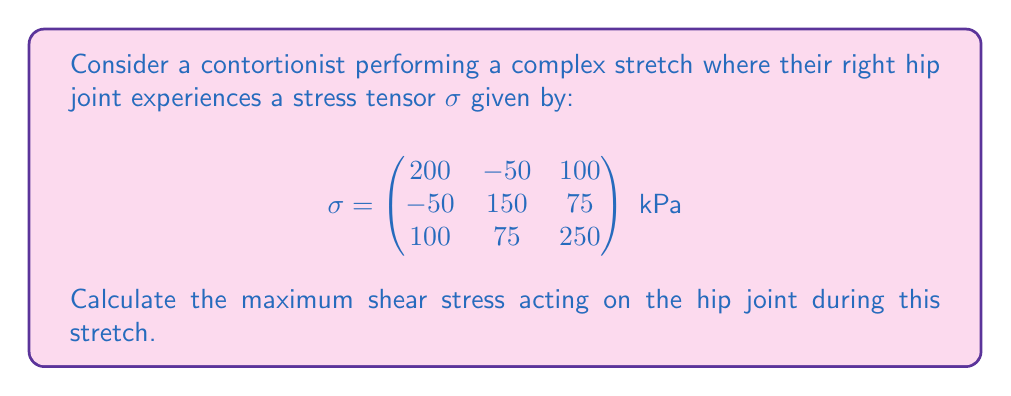Solve this math problem. To find the maximum shear stress, we need to follow these steps:

1) First, we need to calculate the principal stresses. These are the eigenvalues of the stress tensor.

2) The characteristic equation for the eigenvalues λ is:
   $$\det(\sigma - \lambda I) = 0$$

3) Expanding this determinant:
   $$(200-\lambda)(150-\lambda)(250-\lambda) - (-50)^2(250-\lambda) - 100^2(150-\lambda) - 75^2(200-\lambda) + 2(-50)(100)(75) = 0$$

4) This simplifies to:
   $$-\lambda^3 + 600\lambda^2 - 108125\lambda + 5468750 = 0$$

5) Solving this cubic equation (using a calculator or computer algebra system) gives the principal stresses:
   $$\lambda_1 \approx 345.3 \text{ kPa}$$
   $$\lambda_2 \approx 184.9 \text{ kPa}$$
   $$\lambda_3 \approx 69.8 \text{ kPa}$$

6) The maximum shear stress $\tau_{max}$ is given by half the difference between the largest and smallest principal stresses:
   $$\tau_{max} = \frac{1}{2}(\lambda_1 - \lambda_3)$$

7) Substituting the values:
   $$\tau_{max} = \frac{1}{2}(345.3 - 69.8) = 137.75 \text{ kPa}$$
Answer: 137.75 kPa 